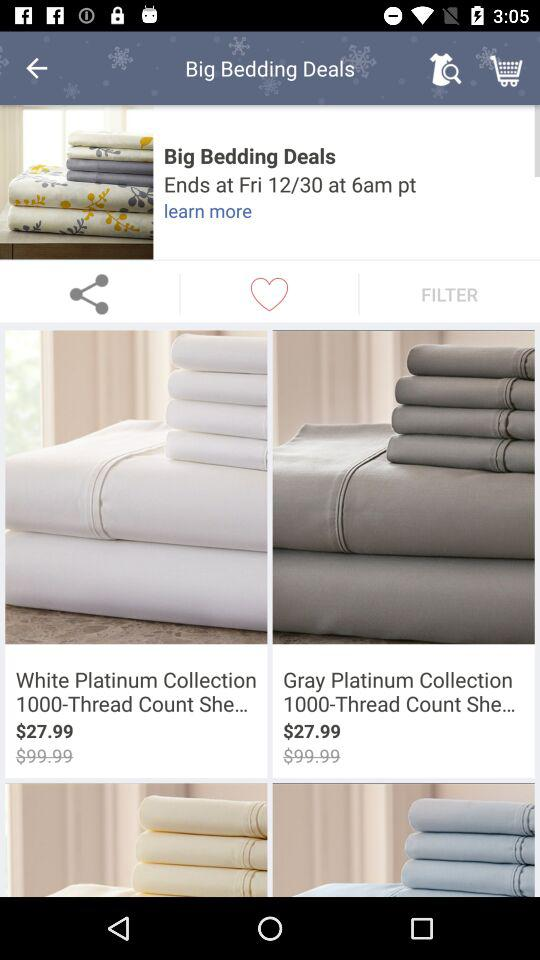How many items are on sale that are not white?
Answer the question using a single word or phrase. 2 